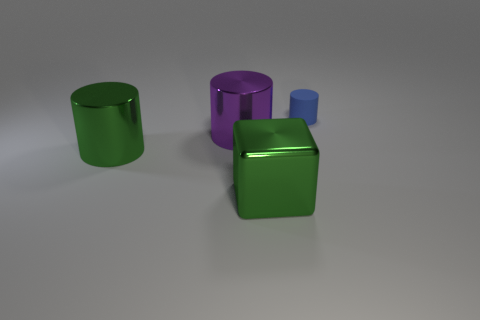How many objects are either blue things or large red blocks?
Provide a succinct answer. 1. What is the material of the object on the right side of the large green shiny object right of the purple metallic object?
Offer a very short reply. Rubber. Are there any yellow things made of the same material as the purple thing?
Keep it short and to the point. No. There is a green metallic thing that is behind the metallic thing that is in front of the metal cylinder left of the purple metal object; what shape is it?
Offer a very short reply. Cylinder. What material is the large purple cylinder?
Your response must be concise. Metal. What is the color of the other large cylinder that is made of the same material as the green cylinder?
Provide a short and direct response. Purple. There is a green object that is to the left of the green shiny block; is there a matte object that is left of it?
Offer a terse response. No. How many other objects are there of the same shape as the purple metallic thing?
Your response must be concise. 2. There is a green object that is to the right of the green metal cylinder; does it have the same shape as the big green shiny thing behind the cube?
Keep it short and to the point. No. There is a shiny cylinder that is behind the green metallic thing that is behind the metal cube; what number of big green metallic things are to the right of it?
Offer a terse response. 1. 